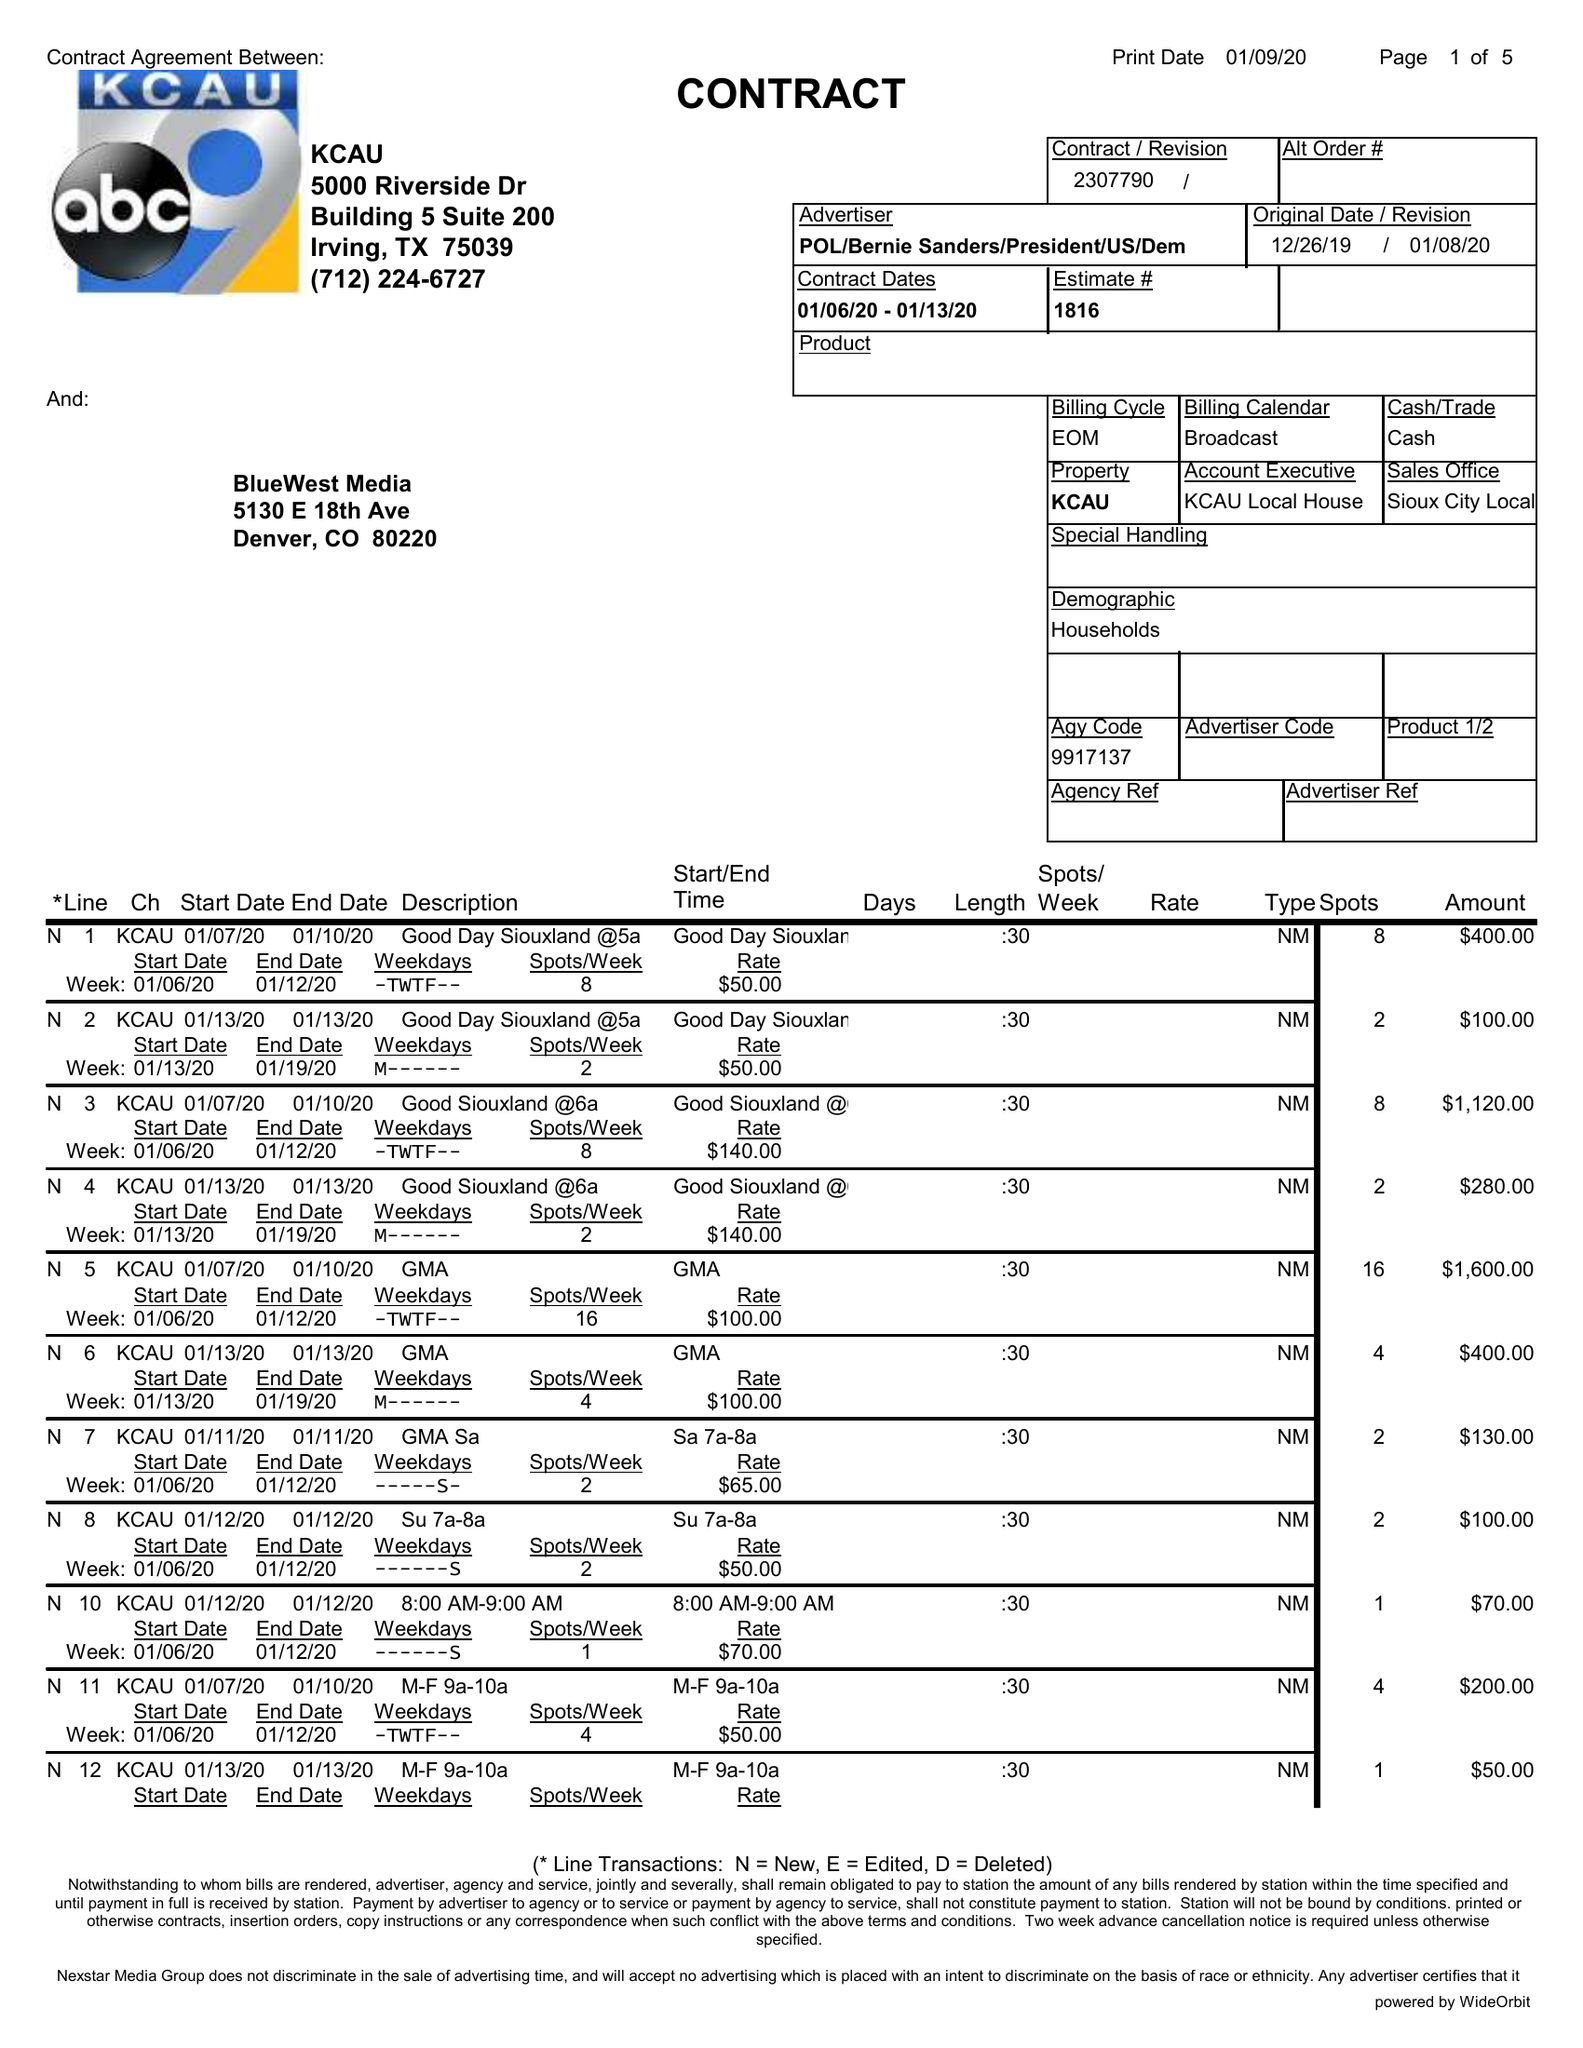What is the value for the advertiser?
Answer the question using a single word or phrase. POL/BERNIESANDERS/PRESIDENT/US/DEM 